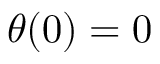Convert formula to latex. <formula><loc_0><loc_0><loc_500><loc_500>\theta ( 0 ) = 0</formula> 